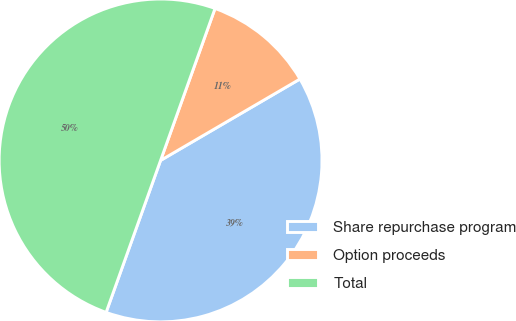Convert chart. <chart><loc_0><loc_0><loc_500><loc_500><pie_chart><fcel>Share repurchase program<fcel>Option proceeds<fcel>Total<nl><fcel>38.89%<fcel>11.11%<fcel>50.0%<nl></chart> 